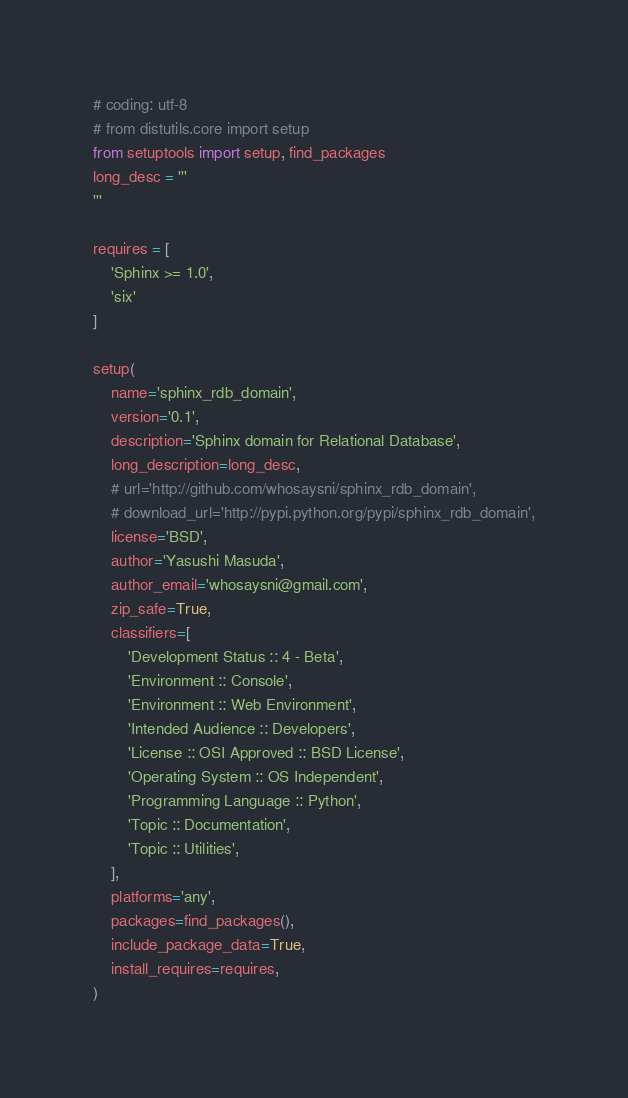Convert code to text. <code><loc_0><loc_0><loc_500><loc_500><_Python_># coding: utf-8
# from distutils.core import setup
from setuptools import setup, find_packages
long_desc = '''
'''

requires = [
    'Sphinx >= 1.0',
    'six'
]

setup(
    name='sphinx_rdb_domain',
    version='0.1',
    description='Sphinx domain for Relational Database',
    long_description=long_desc,
    # url='http://github.com/whosaysni/sphinx_rdb_domain',
    # download_url='http://pypi.python.org/pypi/sphinx_rdb_domain',
    license='BSD',
    author='Yasushi Masuda',
    author_email='whosaysni@gmail.com',
    zip_safe=True,
    classifiers=[
        'Development Status :: 4 - Beta',
        'Environment :: Console',
        'Environment :: Web Environment',
        'Intended Audience :: Developers',
        'License :: OSI Approved :: BSD License',
        'Operating System :: OS Independent',
        'Programming Language :: Python',
        'Topic :: Documentation',
        'Topic :: Utilities',
    ],
    platforms='any',
    packages=find_packages(),
    include_package_data=True,
    install_requires=requires,
)
</code> 